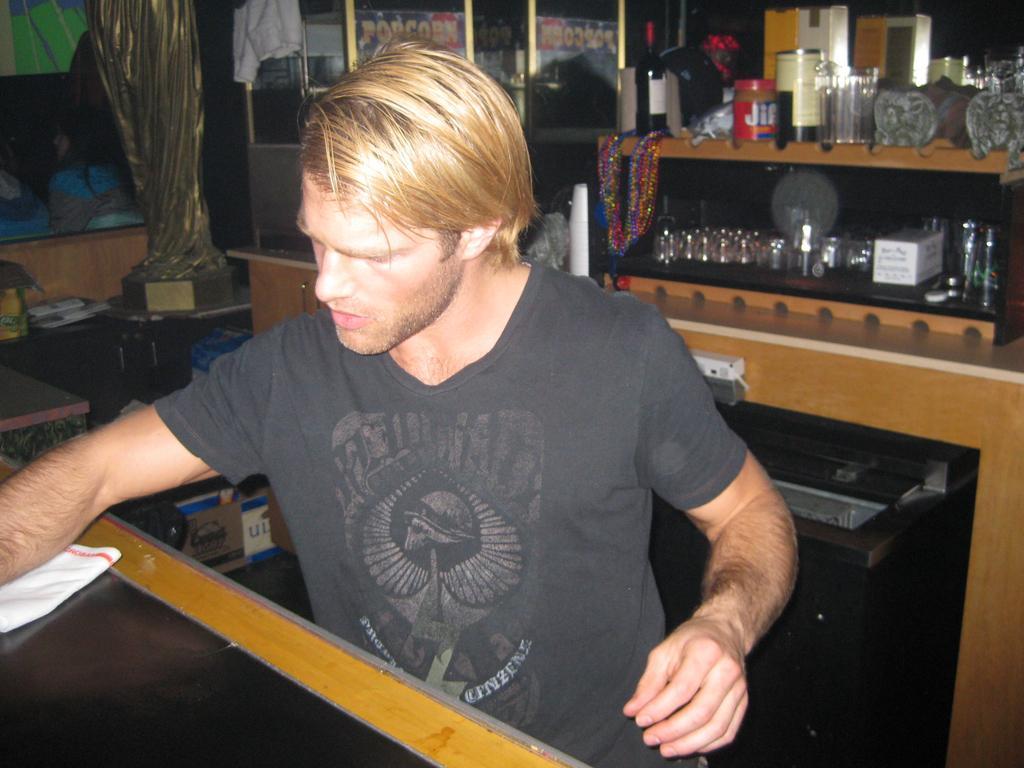Please provide a concise description of this image. In this image I can see a person wearing gray shirt and holding a cloth which is in white color. Background I can see few glasses on the wooden board and I can also see few frames attached to the wall. 